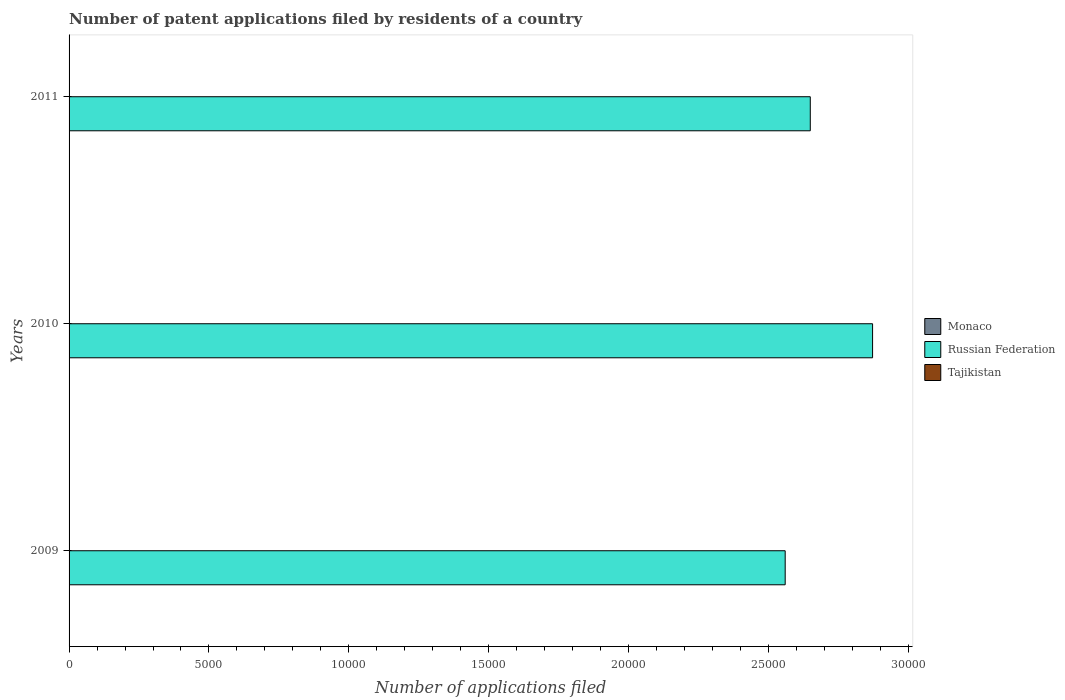How many groups of bars are there?
Keep it short and to the point. 3. How many bars are there on the 3rd tick from the top?
Keep it short and to the point. 3. How many bars are there on the 3rd tick from the bottom?
Your answer should be very brief. 3. In how many cases, is the number of bars for a given year not equal to the number of legend labels?
Give a very brief answer. 0. Across all years, what is the maximum number of applications filed in Monaco?
Your response must be concise. 6. Across all years, what is the minimum number of applications filed in Tajikistan?
Ensure brevity in your answer.  4. In which year was the number of applications filed in Russian Federation maximum?
Your answer should be very brief. 2010. What is the difference between the number of applications filed in Russian Federation in 2009 and that in 2010?
Give a very brief answer. -3124. What is the difference between the number of applications filed in Tajikistan in 2010 and the number of applications filed in Monaco in 2009?
Provide a succinct answer. 4. What is the average number of applications filed in Russian Federation per year?
Offer a very short reply. 2.69e+04. In the year 2011, what is the difference between the number of applications filed in Tajikistan and number of applications filed in Monaco?
Your answer should be very brief. -2. In how many years, is the number of applications filed in Russian Federation greater than 29000 ?
Give a very brief answer. 0. What is the ratio of the number of applications filed in Tajikistan in 2010 to that in 2011?
Provide a short and direct response. 1.75. Is the number of applications filed in Russian Federation in 2010 less than that in 2011?
Your response must be concise. No. What is the difference between the highest and the second highest number of applications filed in Russian Federation?
Keep it short and to the point. 2227. Is the sum of the number of applications filed in Monaco in 2009 and 2010 greater than the maximum number of applications filed in Tajikistan across all years?
Make the answer very short. No. What does the 3rd bar from the top in 2009 represents?
Make the answer very short. Monaco. What does the 2nd bar from the bottom in 2011 represents?
Offer a terse response. Russian Federation. Is it the case that in every year, the sum of the number of applications filed in Monaco and number of applications filed in Russian Federation is greater than the number of applications filed in Tajikistan?
Keep it short and to the point. Yes. How many bars are there?
Offer a very short reply. 9. Are all the bars in the graph horizontal?
Your answer should be compact. Yes. Are the values on the major ticks of X-axis written in scientific E-notation?
Your answer should be compact. No. Does the graph contain any zero values?
Offer a very short reply. No. How are the legend labels stacked?
Offer a terse response. Vertical. What is the title of the graph?
Provide a succinct answer. Number of patent applications filed by residents of a country. Does "Kyrgyz Republic" appear as one of the legend labels in the graph?
Your answer should be very brief. No. What is the label or title of the X-axis?
Give a very brief answer. Number of applications filed. What is the Number of applications filed in Monaco in 2009?
Your response must be concise. 3. What is the Number of applications filed in Russian Federation in 2009?
Ensure brevity in your answer.  2.56e+04. What is the Number of applications filed in Tajikistan in 2009?
Give a very brief answer. 11. What is the Number of applications filed of Russian Federation in 2010?
Your response must be concise. 2.87e+04. What is the Number of applications filed of Tajikistan in 2010?
Provide a short and direct response. 7. What is the Number of applications filed of Russian Federation in 2011?
Make the answer very short. 2.65e+04. Across all years, what is the maximum Number of applications filed in Russian Federation?
Ensure brevity in your answer.  2.87e+04. Across all years, what is the maximum Number of applications filed in Tajikistan?
Offer a very short reply. 11. Across all years, what is the minimum Number of applications filed in Russian Federation?
Provide a short and direct response. 2.56e+04. Across all years, what is the minimum Number of applications filed in Tajikistan?
Offer a terse response. 4. What is the total Number of applications filed of Russian Federation in the graph?
Give a very brief answer. 8.08e+04. What is the difference between the Number of applications filed of Russian Federation in 2009 and that in 2010?
Offer a terse response. -3124. What is the difference between the Number of applications filed of Monaco in 2009 and that in 2011?
Your response must be concise. -3. What is the difference between the Number of applications filed of Russian Federation in 2009 and that in 2011?
Give a very brief answer. -897. What is the difference between the Number of applications filed in Monaco in 2010 and that in 2011?
Your response must be concise. 0. What is the difference between the Number of applications filed of Russian Federation in 2010 and that in 2011?
Make the answer very short. 2227. What is the difference between the Number of applications filed in Tajikistan in 2010 and that in 2011?
Offer a terse response. 3. What is the difference between the Number of applications filed in Monaco in 2009 and the Number of applications filed in Russian Federation in 2010?
Give a very brief answer. -2.87e+04. What is the difference between the Number of applications filed of Russian Federation in 2009 and the Number of applications filed of Tajikistan in 2010?
Give a very brief answer. 2.56e+04. What is the difference between the Number of applications filed in Monaco in 2009 and the Number of applications filed in Russian Federation in 2011?
Ensure brevity in your answer.  -2.65e+04. What is the difference between the Number of applications filed in Monaco in 2009 and the Number of applications filed in Tajikistan in 2011?
Offer a very short reply. -1. What is the difference between the Number of applications filed of Russian Federation in 2009 and the Number of applications filed of Tajikistan in 2011?
Your answer should be very brief. 2.56e+04. What is the difference between the Number of applications filed of Monaco in 2010 and the Number of applications filed of Russian Federation in 2011?
Make the answer very short. -2.65e+04. What is the difference between the Number of applications filed in Monaco in 2010 and the Number of applications filed in Tajikistan in 2011?
Your answer should be compact. 2. What is the difference between the Number of applications filed in Russian Federation in 2010 and the Number of applications filed in Tajikistan in 2011?
Your answer should be very brief. 2.87e+04. What is the average Number of applications filed in Monaco per year?
Keep it short and to the point. 5. What is the average Number of applications filed of Russian Federation per year?
Your response must be concise. 2.69e+04. What is the average Number of applications filed of Tajikistan per year?
Offer a terse response. 7.33. In the year 2009, what is the difference between the Number of applications filed of Monaco and Number of applications filed of Russian Federation?
Your answer should be very brief. -2.56e+04. In the year 2009, what is the difference between the Number of applications filed of Russian Federation and Number of applications filed of Tajikistan?
Offer a terse response. 2.56e+04. In the year 2010, what is the difference between the Number of applications filed of Monaco and Number of applications filed of Russian Federation?
Keep it short and to the point. -2.87e+04. In the year 2010, what is the difference between the Number of applications filed of Monaco and Number of applications filed of Tajikistan?
Ensure brevity in your answer.  -1. In the year 2010, what is the difference between the Number of applications filed of Russian Federation and Number of applications filed of Tajikistan?
Give a very brief answer. 2.87e+04. In the year 2011, what is the difference between the Number of applications filed of Monaco and Number of applications filed of Russian Federation?
Your answer should be compact. -2.65e+04. In the year 2011, what is the difference between the Number of applications filed of Russian Federation and Number of applications filed of Tajikistan?
Offer a very short reply. 2.65e+04. What is the ratio of the Number of applications filed of Monaco in 2009 to that in 2010?
Ensure brevity in your answer.  0.5. What is the ratio of the Number of applications filed of Russian Federation in 2009 to that in 2010?
Your response must be concise. 0.89. What is the ratio of the Number of applications filed of Tajikistan in 2009 to that in 2010?
Ensure brevity in your answer.  1.57. What is the ratio of the Number of applications filed in Monaco in 2009 to that in 2011?
Your answer should be very brief. 0.5. What is the ratio of the Number of applications filed in Russian Federation in 2009 to that in 2011?
Give a very brief answer. 0.97. What is the ratio of the Number of applications filed of Tajikistan in 2009 to that in 2011?
Make the answer very short. 2.75. What is the ratio of the Number of applications filed of Monaco in 2010 to that in 2011?
Your response must be concise. 1. What is the ratio of the Number of applications filed in Russian Federation in 2010 to that in 2011?
Make the answer very short. 1.08. What is the difference between the highest and the second highest Number of applications filed of Russian Federation?
Provide a succinct answer. 2227. What is the difference between the highest and the second highest Number of applications filed of Tajikistan?
Provide a succinct answer. 4. What is the difference between the highest and the lowest Number of applications filed of Monaco?
Your answer should be very brief. 3. What is the difference between the highest and the lowest Number of applications filed in Russian Federation?
Provide a short and direct response. 3124. What is the difference between the highest and the lowest Number of applications filed of Tajikistan?
Your response must be concise. 7. 